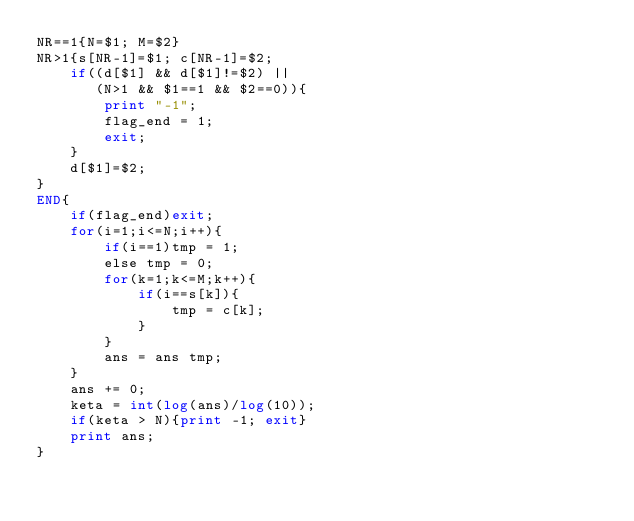<code> <loc_0><loc_0><loc_500><loc_500><_Awk_>NR==1{N=$1; M=$2}
NR>1{s[NR-1]=$1; c[NR-1]=$2;
	if((d[$1] && d[$1]!=$2) ||
       (N>1 && $1==1 && $2==0)){
    	print "-1";
        flag_end = 1;
        exit;
    }
    d[$1]=$2;
}
END{
	if(flag_end)exit;
    for(i=1;i<=N;i++){
    	if(i==1)tmp = 1;
        else tmp = 0;
		for(k=1;k<=M;k++){
        	if(i==s[k]){
            	tmp = c[k];
            }
        }
        ans = ans tmp;
    }
    ans += 0;
    keta = int(log(ans)/log(10));
    if(keta > N){print -1; exit}
    print ans;
}</code> 